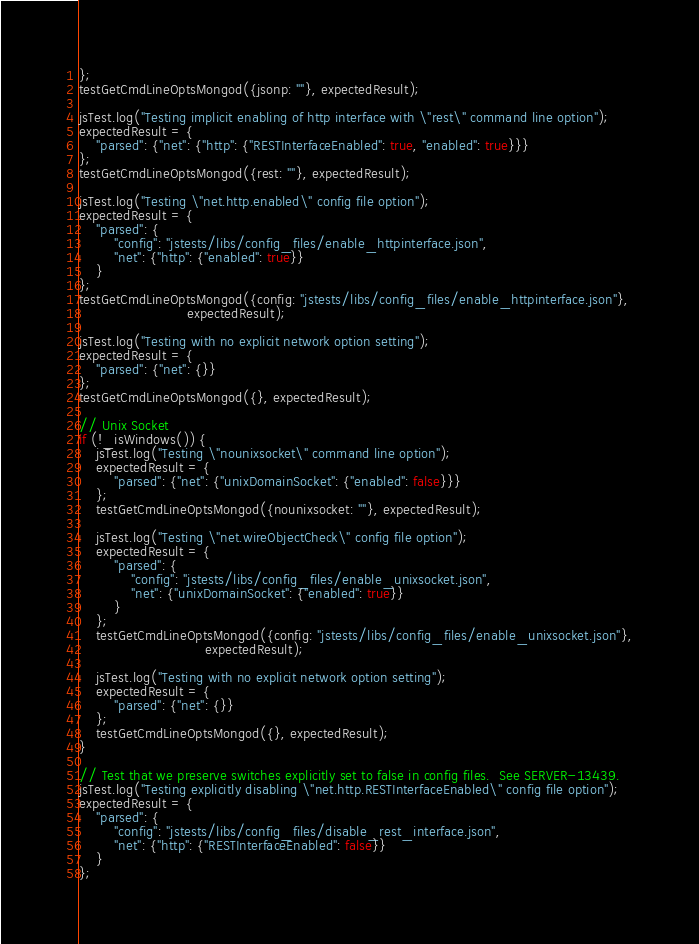<code> <loc_0><loc_0><loc_500><loc_500><_JavaScript_>};
testGetCmdLineOptsMongod({jsonp: ""}, expectedResult);

jsTest.log("Testing implicit enabling of http interface with \"rest\" command line option");
expectedResult = {
    "parsed": {"net": {"http": {"RESTInterfaceEnabled": true, "enabled": true}}}
};
testGetCmdLineOptsMongod({rest: ""}, expectedResult);

jsTest.log("Testing \"net.http.enabled\" config file option");
expectedResult = {
    "parsed": {
        "config": "jstests/libs/config_files/enable_httpinterface.json",
        "net": {"http": {"enabled": true}}
    }
};
testGetCmdLineOptsMongod({config: "jstests/libs/config_files/enable_httpinterface.json"},
                         expectedResult);

jsTest.log("Testing with no explicit network option setting");
expectedResult = {
    "parsed": {"net": {}}
};
testGetCmdLineOptsMongod({}, expectedResult);

// Unix Socket
if (!_isWindows()) {
    jsTest.log("Testing \"nounixsocket\" command line option");
    expectedResult = {
        "parsed": {"net": {"unixDomainSocket": {"enabled": false}}}
    };
    testGetCmdLineOptsMongod({nounixsocket: ""}, expectedResult);

    jsTest.log("Testing \"net.wireObjectCheck\" config file option");
    expectedResult = {
        "parsed": {
            "config": "jstests/libs/config_files/enable_unixsocket.json",
            "net": {"unixDomainSocket": {"enabled": true}}
        }
    };
    testGetCmdLineOptsMongod({config: "jstests/libs/config_files/enable_unixsocket.json"},
                             expectedResult);

    jsTest.log("Testing with no explicit network option setting");
    expectedResult = {
        "parsed": {"net": {}}
    };
    testGetCmdLineOptsMongod({}, expectedResult);
}

// Test that we preserve switches explicitly set to false in config files.  See SERVER-13439.
jsTest.log("Testing explicitly disabling \"net.http.RESTInterfaceEnabled\" config file option");
expectedResult = {
    "parsed": {
        "config": "jstests/libs/config_files/disable_rest_interface.json",
        "net": {"http": {"RESTInterfaceEnabled": false}}
    }
};</code> 